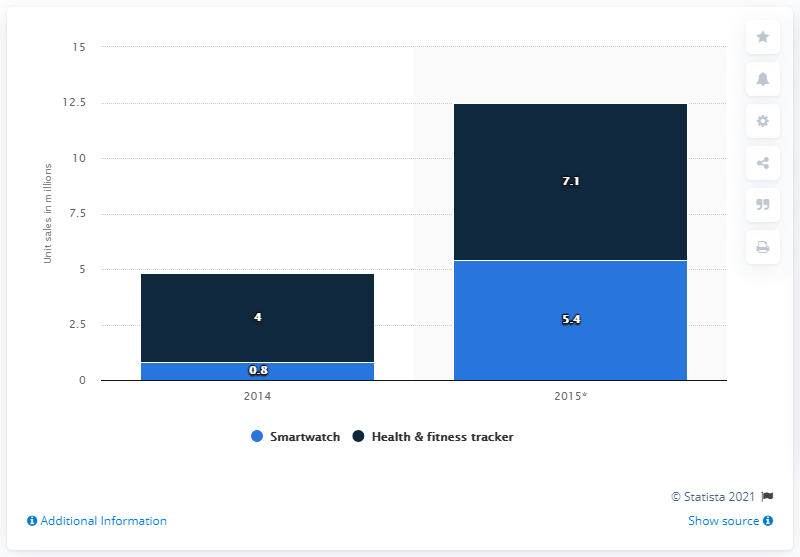Highlight a few significant elements in this photo. According to forecasts, an estimated 5.4 units of smartwatches are predicted to be sold in Western Europe in 2015. 